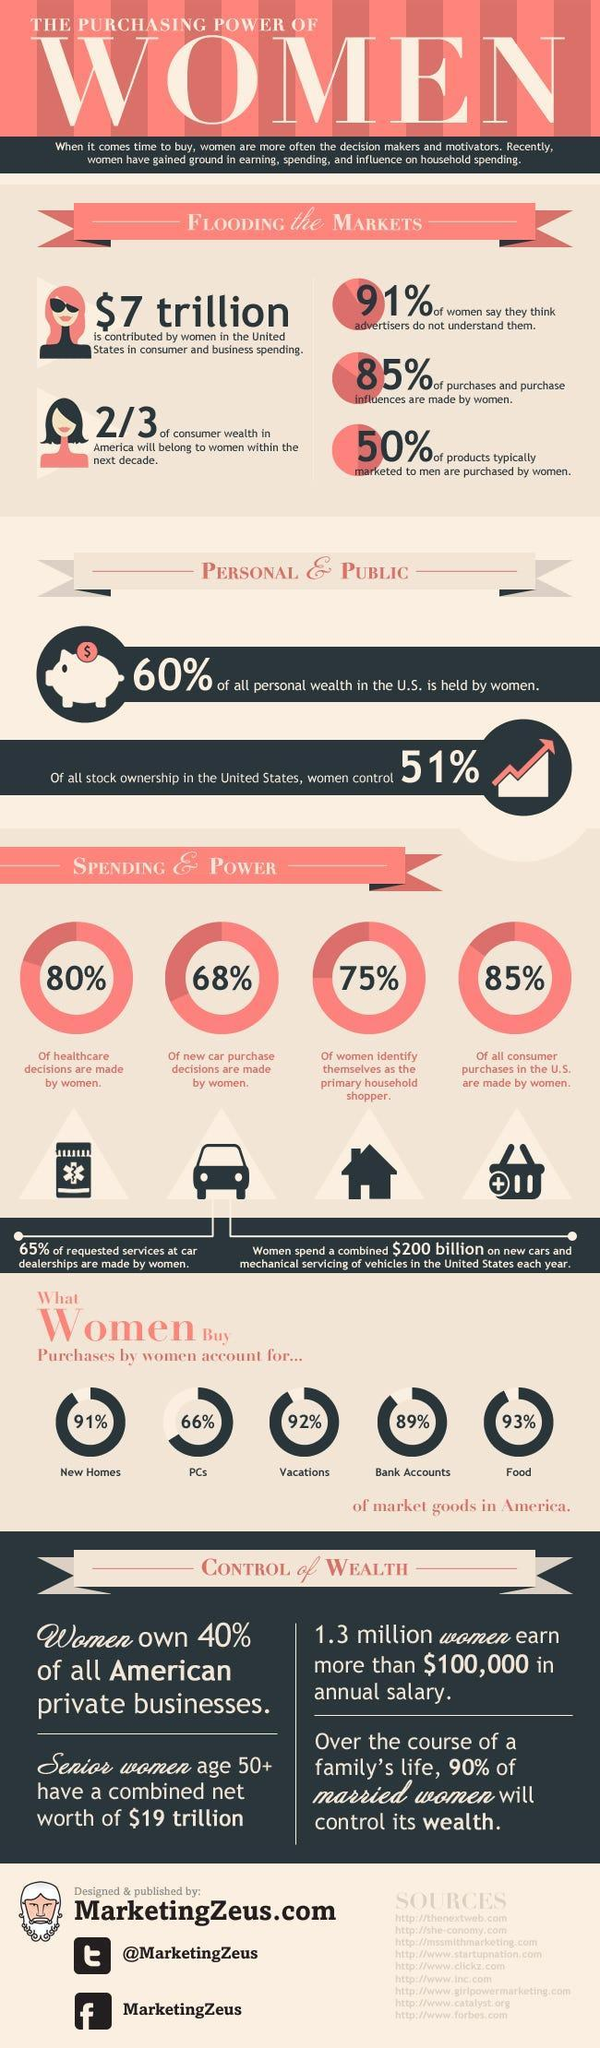What percentage of new homes are purchased by women in the US?
Answer the question with a short phrase. 91% What percentage of men's products are bought by women? 50% What percent of new car purchase decisions are made by women? 68% Who owns lesser stock in the United States, men or women? Men Who is expected to have a higher control over money in a family, in the future? Married women What percentage of private businesses in the US belong to women? 40% What is the expenditure on servicing and purchase of vehicles made by women in the US each year? $ 200 billion What percentage of PCs are purchased by women in the US? 66% What percentage of women identify themselves as primary household shoppers? 75% What percentage of all consumer purchases in the United States are made by women? 85% What percentage of healthcare decisions are made by women? 80% What is the total contribution of women in consumer and business spending in the United States? $ 7 trillion Which market goods have more than 90% of purchases made by women? New homes, vacations, food What percentage of women feel they are misunderstood by advertisers? 91% What percentage of food purchases are made by women in US? 93% What percentage of purchases and purchase influences are 'not' made by women? 15% 